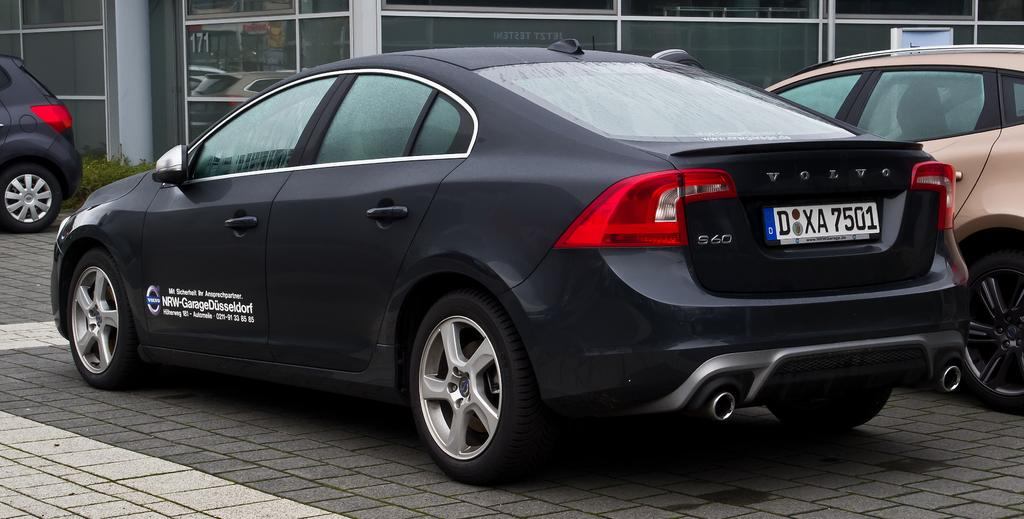What type of vehicles are on the ground in the image? There are cars on the ground in the image. What structure can be seen in the image? There is a building in the image. What type of natural elements are present in the image? There are plants in the image. What is attached to the building in the image? There is a box attached to the building in the image. How many spiders are crawling on the cars in the image? There are no spiders present in the image; it only features cars, a building, plants, and a box attached to the building. 